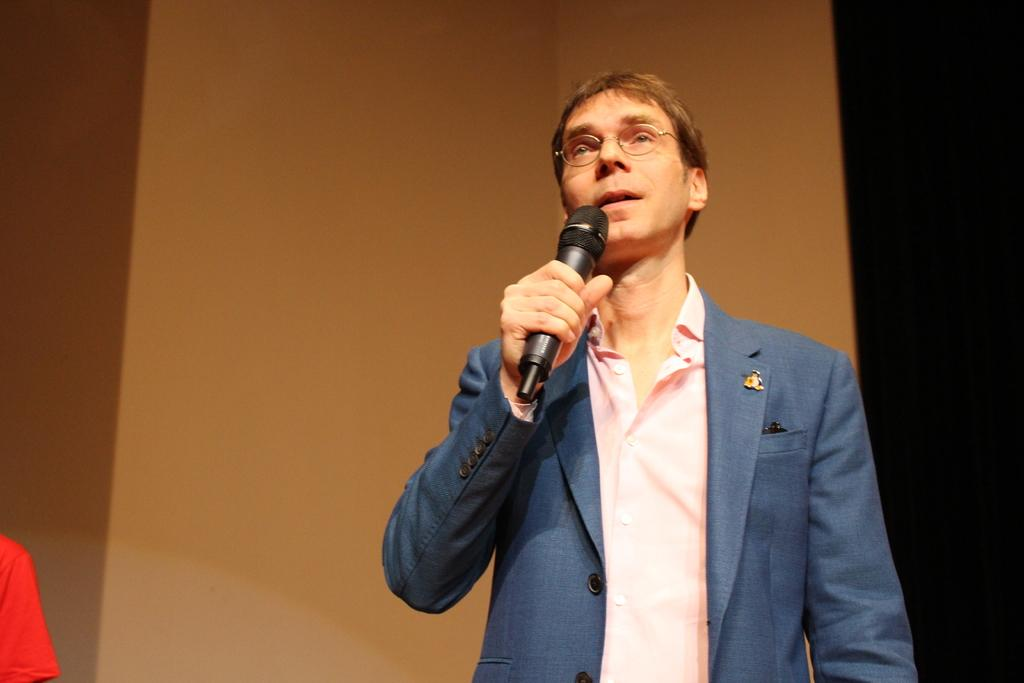What is the main subject of the image? There is a man in the image. What is the man doing in the image? The man is standing and speaking in the image. What object is the man holding in his hand? The man is holding a microphone in his hand. How many attempts did the person make to tie the string in the image? There is no person or string present in the image. What type of person is depicted in the image? The image only shows a man, so there is no other person depicted. 